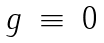Convert formula to latex. <formula><loc_0><loc_0><loc_500><loc_500>\begin{array} { r c l } g & \equiv & 0 \end{array}</formula> 